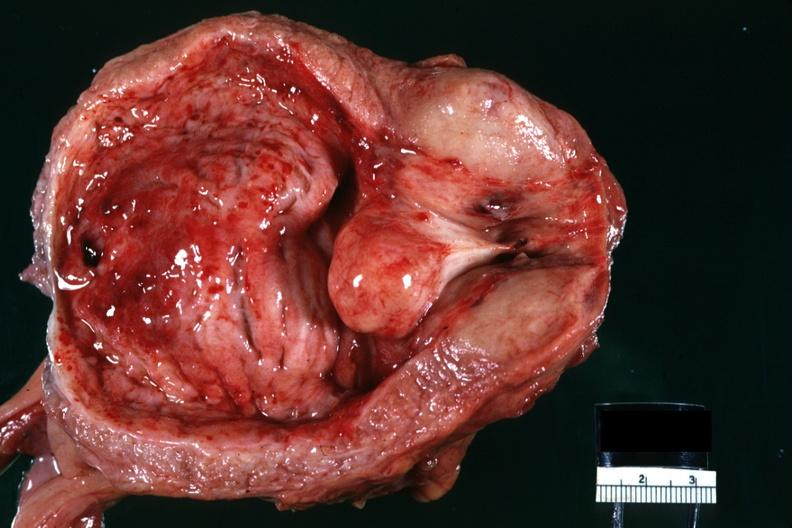what is present?
Answer the question using a single word or phrase. Prostate 